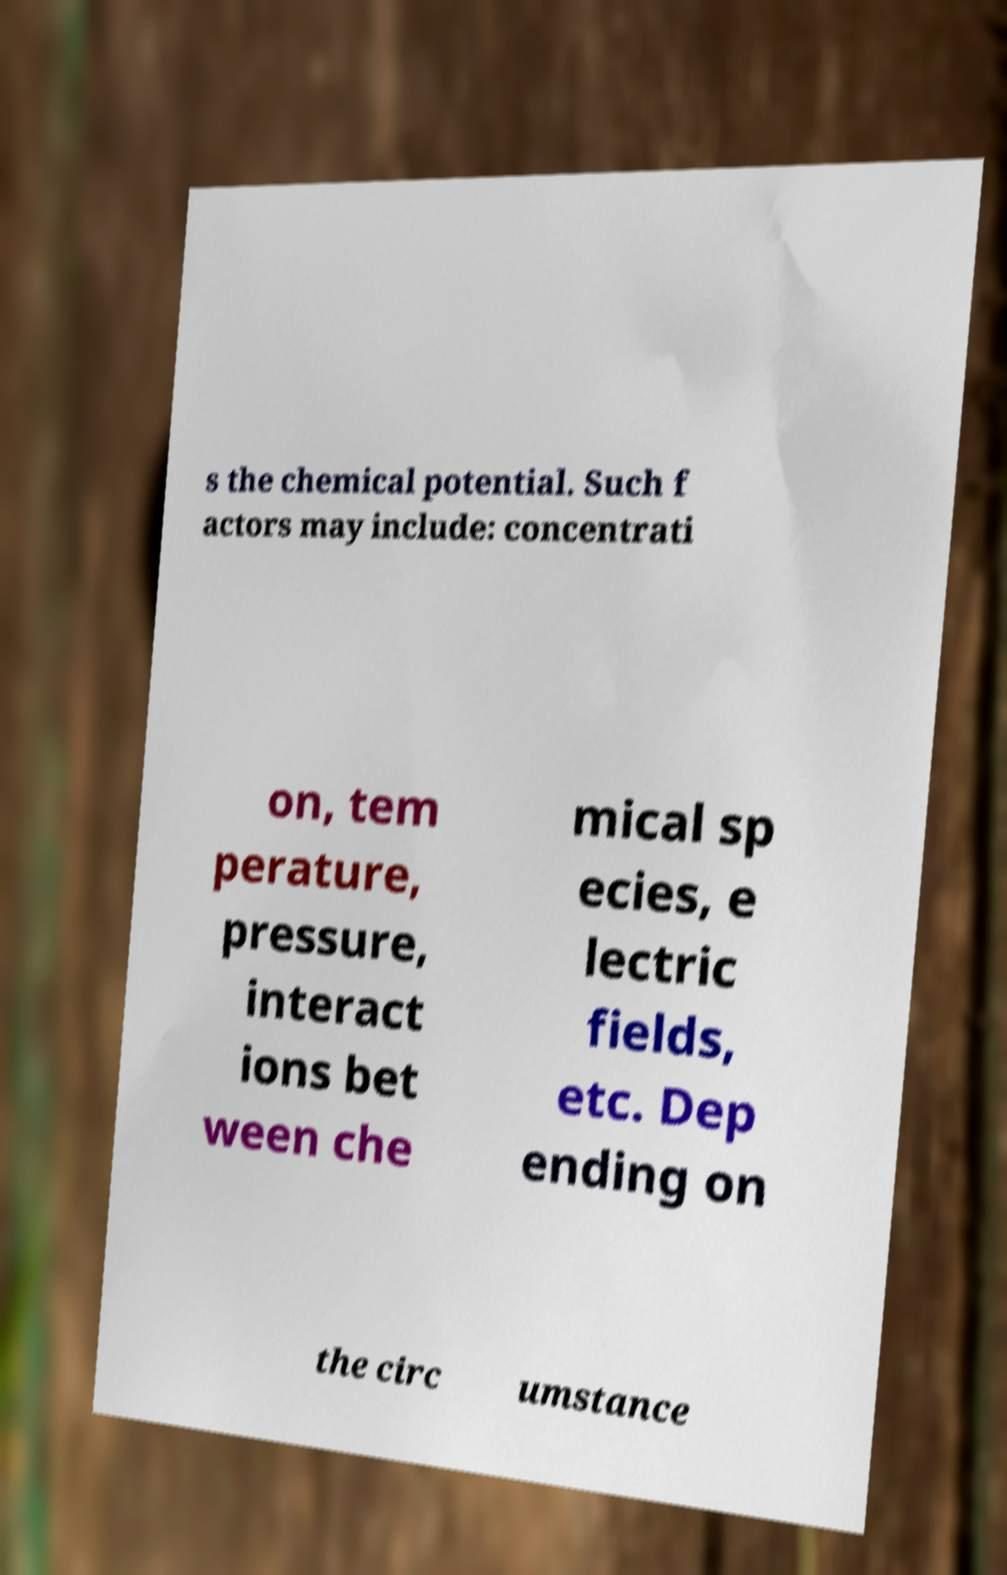Can you read and provide the text displayed in the image?This photo seems to have some interesting text. Can you extract and type it out for me? s the chemical potential. Such f actors may include: concentrati on, tem perature, pressure, interact ions bet ween che mical sp ecies, e lectric fields, etc. Dep ending on the circ umstance 